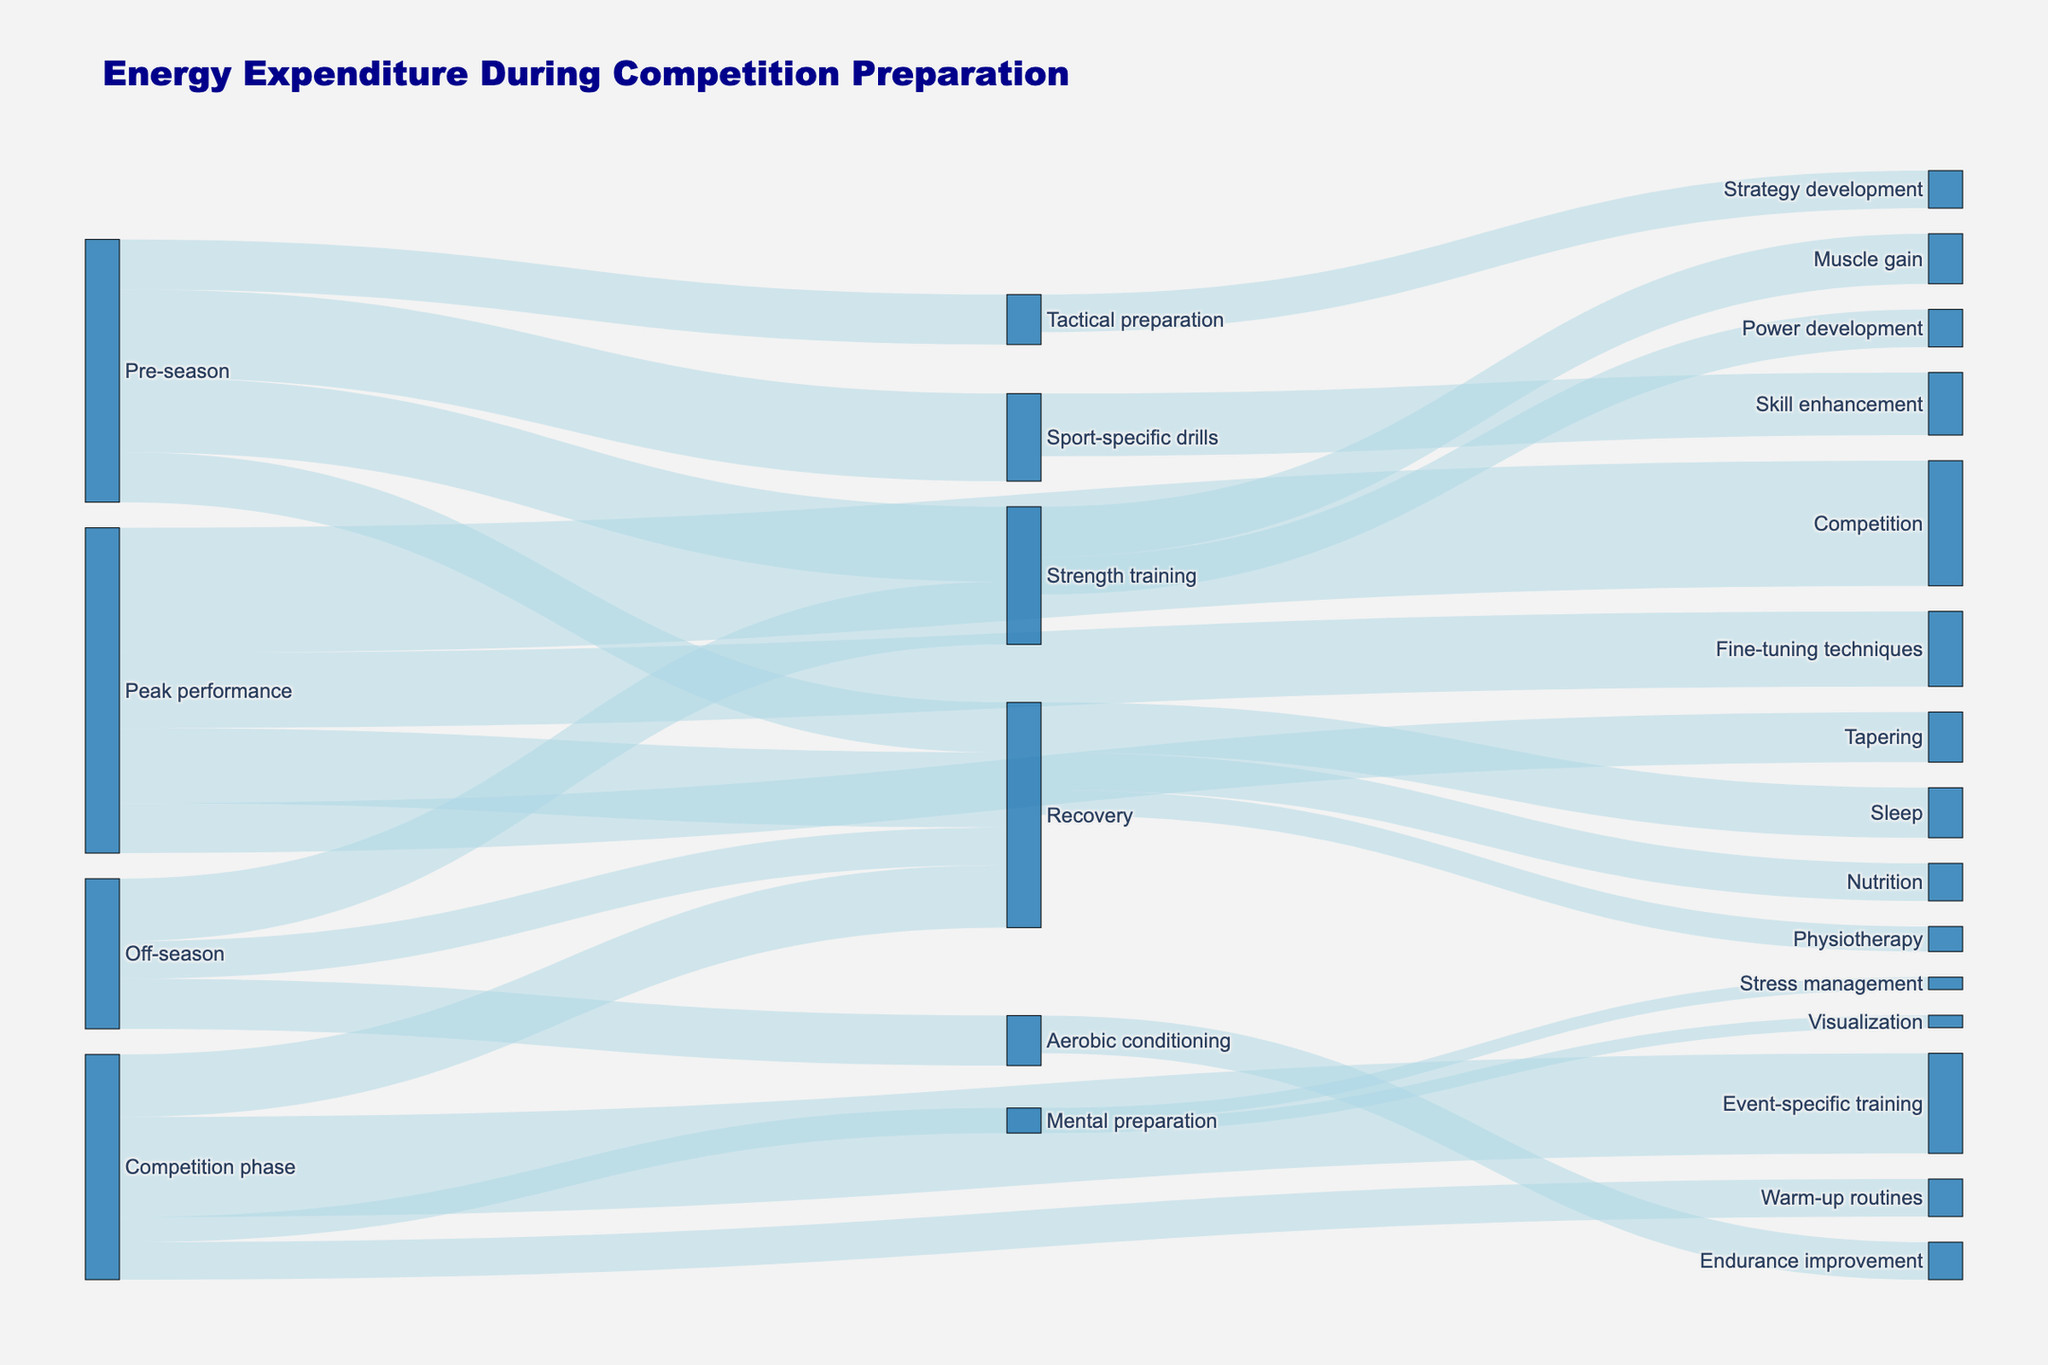What's the title of the figure? The title is displayed at the top of the figure.
Answer: Energy Expenditure During Competition Preparation How many different phases of competition preparation are illustrated in the figure? Check the major categories from where energy expenditure transitions originate: Off-season, Pre-season, Competition phase, and Peak performance.
Answer: 4 Which phase allocates the most energy to Recovery? Look for the phase with the highest value allocated to Recovery. Peak performance has a value of 3000, while other phases have lower values.
Answer: Peak performance What's the total energy expenditure for Pre-season activities? Sum the values from Pre-season to other targets: (3000 + 3500 + 2000 + 2000).
Answer: 10500 During the Competition phase, which activity receives the least energy? Compare the target values under Competition phase. Mental preparation receives 1000, which is the smallest.
Answer: Mental preparation What's the combined energy expenditure on Strength training across all phases? Add the values of Strength training from each phase it appears in: (2500 + 3000).
Answer: 5500 Is more energy allocated to Muscle gain or Power development? Compare the values linked from Strength training to Muscle gain (2000) and Power development (1500).
Answer: Muscle gain How does the energy expenditure for Recovery during the Competition phase compare to the Off-season? Compare the values: Competition phase (2500) and Off-season (1500).
Answer: Competition phase is higher What's the total energy allocated to Mental preparation and its sub-categories during the Competition phase? Add the value of Mental preparation and its sub-categories Visualization and Stress management (1000 + 500 + 500).
Answer: 2000 Does the energy allocation for Fine-tuning techniques exceed Tapering in Peak performance? Compare the values of Fine-tuning techniques (3000) and Tapering (2000).
Answer: Yes 